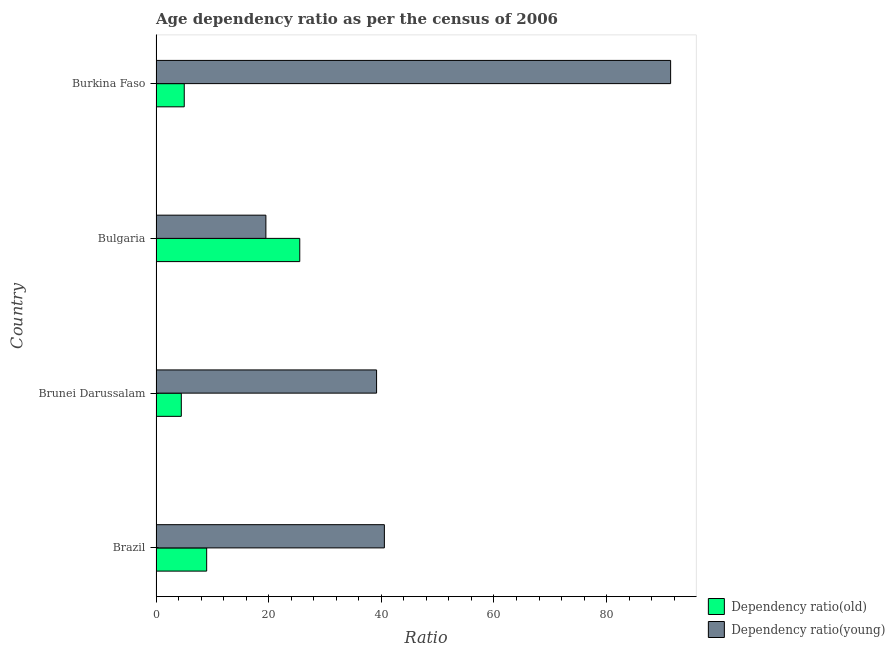Are the number of bars on each tick of the Y-axis equal?
Keep it short and to the point. Yes. How many bars are there on the 4th tick from the top?
Make the answer very short. 2. How many bars are there on the 4th tick from the bottom?
Give a very brief answer. 2. What is the label of the 3rd group of bars from the top?
Provide a short and direct response. Brunei Darussalam. What is the age dependency ratio(young) in Brazil?
Make the answer very short. 40.54. Across all countries, what is the maximum age dependency ratio(old)?
Your answer should be compact. 25.52. Across all countries, what is the minimum age dependency ratio(old)?
Provide a succinct answer. 4.49. In which country was the age dependency ratio(young) maximum?
Offer a terse response. Burkina Faso. In which country was the age dependency ratio(old) minimum?
Keep it short and to the point. Brunei Darussalam. What is the total age dependency ratio(old) in the graph?
Your response must be concise. 44.01. What is the difference between the age dependency ratio(old) in Bulgaria and that in Burkina Faso?
Make the answer very short. 20.51. What is the difference between the age dependency ratio(young) in Burkina Faso and the age dependency ratio(old) in Brunei Darussalam?
Provide a succinct answer. 86.87. What is the average age dependency ratio(young) per country?
Give a very brief answer. 47.64. What is the difference between the age dependency ratio(young) and age dependency ratio(old) in Bulgaria?
Make the answer very short. -6.01. In how many countries, is the age dependency ratio(old) greater than 36 ?
Keep it short and to the point. 0. What is the ratio of the age dependency ratio(old) in Bulgaria to that in Burkina Faso?
Keep it short and to the point. 5.09. Is the difference between the age dependency ratio(young) in Brazil and Brunei Darussalam greater than the difference between the age dependency ratio(old) in Brazil and Brunei Darussalam?
Offer a terse response. No. What is the difference between the highest and the second highest age dependency ratio(young)?
Your answer should be very brief. 50.82. What is the difference between the highest and the lowest age dependency ratio(young)?
Your response must be concise. 71.85. Is the sum of the age dependency ratio(young) in Brazil and Brunei Darussalam greater than the maximum age dependency ratio(old) across all countries?
Your answer should be very brief. Yes. What does the 2nd bar from the top in Brazil represents?
Provide a succinct answer. Dependency ratio(old). What does the 1st bar from the bottom in Brazil represents?
Offer a terse response. Dependency ratio(old). How many bars are there?
Offer a terse response. 8. How many countries are there in the graph?
Offer a very short reply. 4. What is the difference between two consecutive major ticks on the X-axis?
Your answer should be compact. 20. Does the graph contain any zero values?
Provide a succinct answer. No. Where does the legend appear in the graph?
Offer a terse response. Bottom right. How many legend labels are there?
Your answer should be compact. 2. How are the legend labels stacked?
Make the answer very short. Vertical. What is the title of the graph?
Offer a terse response. Age dependency ratio as per the census of 2006. Does "Primary completion rate" appear as one of the legend labels in the graph?
Make the answer very short. No. What is the label or title of the X-axis?
Your response must be concise. Ratio. What is the label or title of the Y-axis?
Provide a short and direct response. Country. What is the Ratio of Dependency ratio(old) in Brazil?
Your response must be concise. 8.99. What is the Ratio in Dependency ratio(young) in Brazil?
Your answer should be compact. 40.54. What is the Ratio in Dependency ratio(old) in Brunei Darussalam?
Provide a succinct answer. 4.49. What is the Ratio in Dependency ratio(young) in Brunei Darussalam?
Ensure brevity in your answer.  39.16. What is the Ratio in Dependency ratio(old) in Bulgaria?
Offer a terse response. 25.52. What is the Ratio of Dependency ratio(young) in Bulgaria?
Your answer should be very brief. 19.5. What is the Ratio in Dependency ratio(old) in Burkina Faso?
Your response must be concise. 5.01. What is the Ratio of Dependency ratio(young) in Burkina Faso?
Your answer should be very brief. 91.36. Across all countries, what is the maximum Ratio in Dependency ratio(old)?
Your answer should be compact. 25.52. Across all countries, what is the maximum Ratio of Dependency ratio(young)?
Your answer should be very brief. 91.36. Across all countries, what is the minimum Ratio of Dependency ratio(old)?
Ensure brevity in your answer.  4.49. Across all countries, what is the minimum Ratio of Dependency ratio(young)?
Offer a terse response. 19.5. What is the total Ratio in Dependency ratio(old) in the graph?
Your answer should be compact. 44.01. What is the total Ratio in Dependency ratio(young) in the graph?
Provide a short and direct response. 190.56. What is the difference between the Ratio in Dependency ratio(old) in Brazil and that in Brunei Darussalam?
Give a very brief answer. 4.5. What is the difference between the Ratio in Dependency ratio(young) in Brazil and that in Brunei Darussalam?
Make the answer very short. 1.38. What is the difference between the Ratio in Dependency ratio(old) in Brazil and that in Bulgaria?
Give a very brief answer. -16.53. What is the difference between the Ratio in Dependency ratio(young) in Brazil and that in Bulgaria?
Make the answer very short. 21.04. What is the difference between the Ratio of Dependency ratio(old) in Brazil and that in Burkina Faso?
Provide a succinct answer. 3.98. What is the difference between the Ratio in Dependency ratio(young) in Brazil and that in Burkina Faso?
Provide a succinct answer. -50.82. What is the difference between the Ratio of Dependency ratio(old) in Brunei Darussalam and that in Bulgaria?
Provide a short and direct response. -21.03. What is the difference between the Ratio in Dependency ratio(young) in Brunei Darussalam and that in Bulgaria?
Your answer should be very brief. 19.65. What is the difference between the Ratio in Dependency ratio(old) in Brunei Darussalam and that in Burkina Faso?
Provide a short and direct response. -0.52. What is the difference between the Ratio in Dependency ratio(young) in Brunei Darussalam and that in Burkina Faso?
Your answer should be compact. -52.2. What is the difference between the Ratio in Dependency ratio(old) in Bulgaria and that in Burkina Faso?
Ensure brevity in your answer.  20.51. What is the difference between the Ratio of Dependency ratio(young) in Bulgaria and that in Burkina Faso?
Give a very brief answer. -71.85. What is the difference between the Ratio of Dependency ratio(old) in Brazil and the Ratio of Dependency ratio(young) in Brunei Darussalam?
Make the answer very short. -30.16. What is the difference between the Ratio of Dependency ratio(old) in Brazil and the Ratio of Dependency ratio(young) in Bulgaria?
Ensure brevity in your answer.  -10.51. What is the difference between the Ratio of Dependency ratio(old) in Brazil and the Ratio of Dependency ratio(young) in Burkina Faso?
Provide a succinct answer. -82.37. What is the difference between the Ratio of Dependency ratio(old) in Brunei Darussalam and the Ratio of Dependency ratio(young) in Bulgaria?
Keep it short and to the point. -15.01. What is the difference between the Ratio of Dependency ratio(old) in Brunei Darussalam and the Ratio of Dependency ratio(young) in Burkina Faso?
Provide a short and direct response. -86.87. What is the difference between the Ratio in Dependency ratio(old) in Bulgaria and the Ratio in Dependency ratio(young) in Burkina Faso?
Your answer should be very brief. -65.84. What is the average Ratio of Dependency ratio(old) per country?
Provide a succinct answer. 11. What is the average Ratio of Dependency ratio(young) per country?
Offer a terse response. 47.64. What is the difference between the Ratio in Dependency ratio(old) and Ratio in Dependency ratio(young) in Brazil?
Give a very brief answer. -31.55. What is the difference between the Ratio of Dependency ratio(old) and Ratio of Dependency ratio(young) in Brunei Darussalam?
Give a very brief answer. -34.66. What is the difference between the Ratio in Dependency ratio(old) and Ratio in Dependency ratio(young) in Bulgaria?
Offer a terse response. 6.01. What is the difference between the Ratio in Dependency ratio(old) and Ratio in Dependency ratio(young) in Burkina Faso?
Offer a terse response. -86.35. What is the ratio of the Ratio in Dependency ratio(old) in Brazil to that in Brunei Darussalam?
Offer a very short reply. 2. What is the ratio of the Ratio of Dependency ratio(young) in Brazil to that in Brunei Darussalam?
Your response must be concise. 1.04. What is the ratio of the Ratio of Dependency ratio(old) in Brazil to that in Bulgaria?
Keep it short and to the point. 0.35. What is the ratio of the Ratio of Dependency ratio(young) in Brazil to that in Bulgaria?
Your answer should be compact. 2.08. What is the ratio of the Ratio in Dependency ratio(old) in Brazil to that in Burkina Faso?
Offer a terse response. 1.79. What is the ratio of the Ratio of Dependency ratio(young) in Brazil to that in Burkina Faso?
Your answer should be compact. 0.44. What is the ratio of the Ratio of Dependency ratio(old) in Brunei Darussalam to that in Bulgaria?
Ensure brevity in your answer.  0.18. What is the ratio of the Ratio in Dependency ratio(young) in Brunei Darussalam to that in Bulgaria?
Offer a terse response. 2.01. What is the ratio of the Ratio in Dependency ratio(old) in Brunei Darussalam to that in Burkina Faso?
Provide a short and direct response. 0.9. What is the ratio of the Ratio of Dependency ratio(young) in Brunei Darussalam to that in Burkina Faso?
Offer a very short reply. 0.43. What is the ratio of the Ratio of Dependency ratio(old) in Bulgaria to that in Burkina Faso?
Your answer should be compact. 5.09. What is the ratio of the Ratio in Dependency ratio(young) in Bulgaria to that in Burkina Faso?
Keep it short and to the point. 0.21. What is the difference between the highest and the second highest Ratio of Dependency ratio(old)?
Your answer should be very brief. 16.53. What is the difference between the highest and the second highest Ratio of Dependency ratio(young)?
Give a very brief answer. 50.82. What is the difference between the highest and the lowest Ratio in Dependency ratio(old)?
Provide a short and direct response. 21.03. What is the difference between the highest and the lowest Ratio of Dependency ratio(young)?
Ensure brevity in your answer.  71.85. 